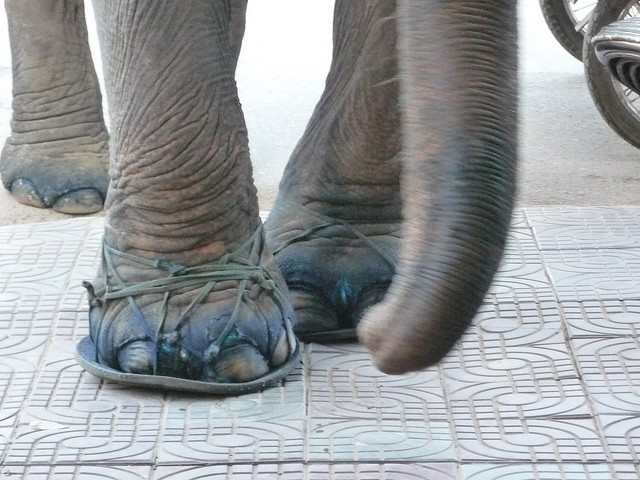Describe the objects in this image and their specific colors. I can see a elephant in white, gray, darkgray, and black tones in this image. 